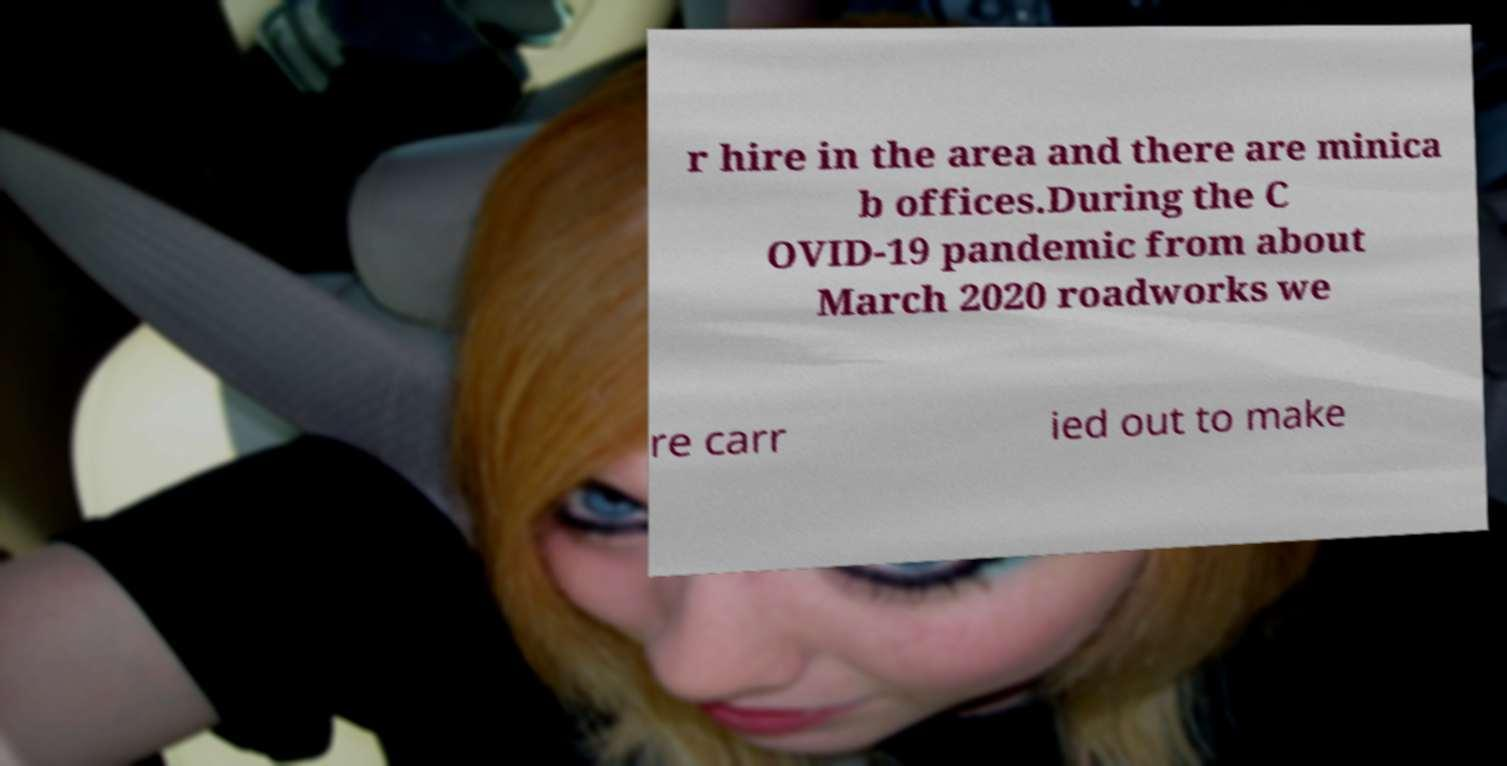Please read and relay the text visible in this image. What does it say? r hire in the area and there are minica b offices.During the C OVID-19 pandemic from about March 2020 roadworks we re carr ied out to make 